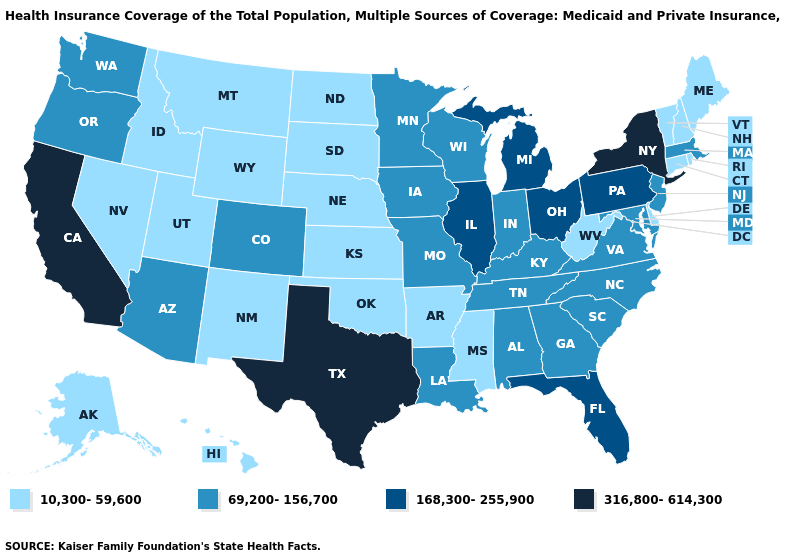What is the value of Indiana?
Quick response, please. 69,200-156,700. What is the value of Georgia?
Quick response, please. 69,200-156,700. Among the states that border North Dakota , does Montana have the lowest value?
Give a very brief answer. Yes. Name the states that have a value in the range 10,300-59,600?
Write a very short answer. Alaska, Arkansas, Connecticut, Delaware, Hawaii, Idaho, Kansas, Maine, Mississippi, Montana, Nebraska, Nevada, New Hampshire, New Mexico, North Dakota, Oklahoma, Rhode Island, South Dakota, Utah, Vermont, West Virginia, Wyoming. What is the value of Montana?
Quick response, please. 10,300-59,600. Among the states that border Rhode Island , does Connecticut have the highest value?
Write a very short answer. No. Does Georgia have the same value as Nevada?
Answer briefly. No. Among the states that border Wyoming , which have the lowest value?
Give a very brief answer. Idaho, Montana, Nebraska, South Dakota, Utah. Does Ohio have the highest value in the MidWest?
Write a very short answer. Yes. Does Hawaii have a higher value than Rhode Island?
Quick response, please. No. Name the states that have a value in the range 316,800-614,300?
Short answer required. California, New York, Texas. What is the value of Louisiana?
Give a very brief answer. 69,200-156,700. What is the value of Wyoming?
Be succinct. 10,300-59,600. Does the first symbol in the legend represent the smallest category?
Be succinct. Yes. Does New Jersey have the lowest value in the USA?
Concise answer only. No. 